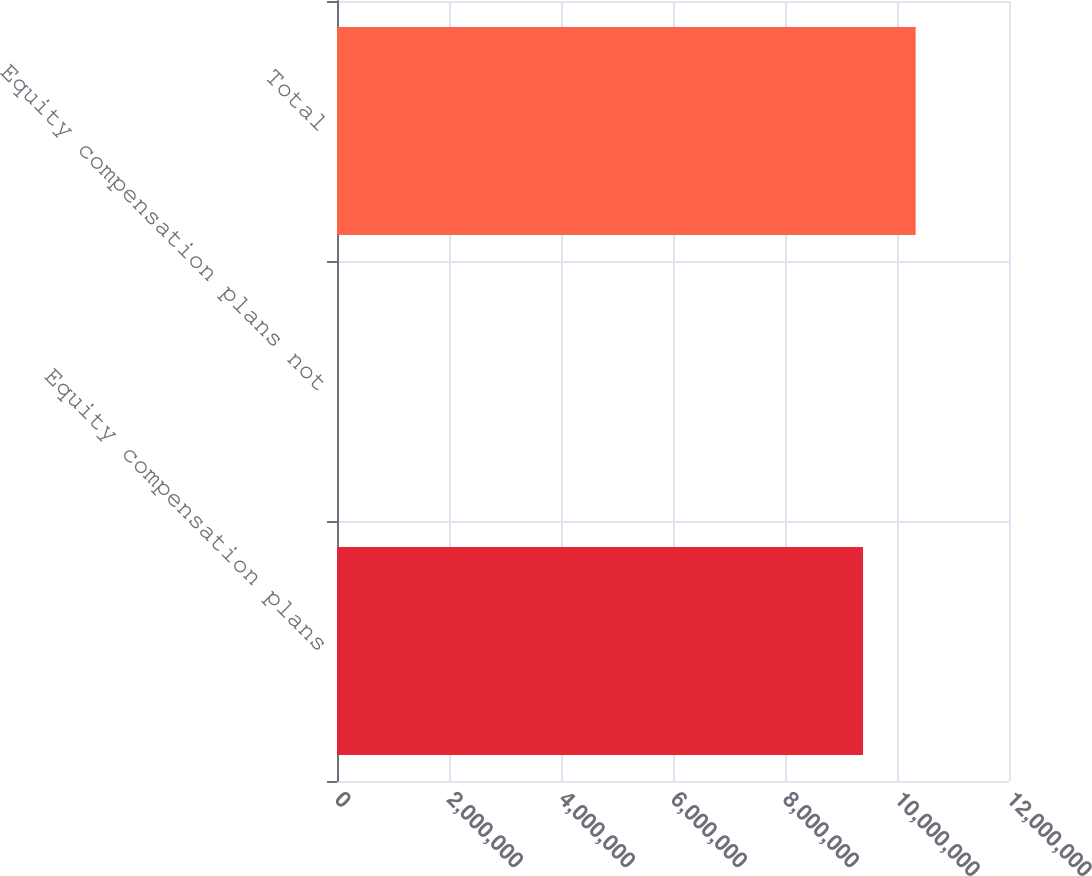<chart> <loc_0><loc_0><loc_500><loc_500><bar_chart><fcel>Equity compensation plans<fcel>Equity compensation plans not<fcel>Total<nl><fcel>9.39392e+06<fcel>3.89<fcel>1.03333e+07<nl></chart> 